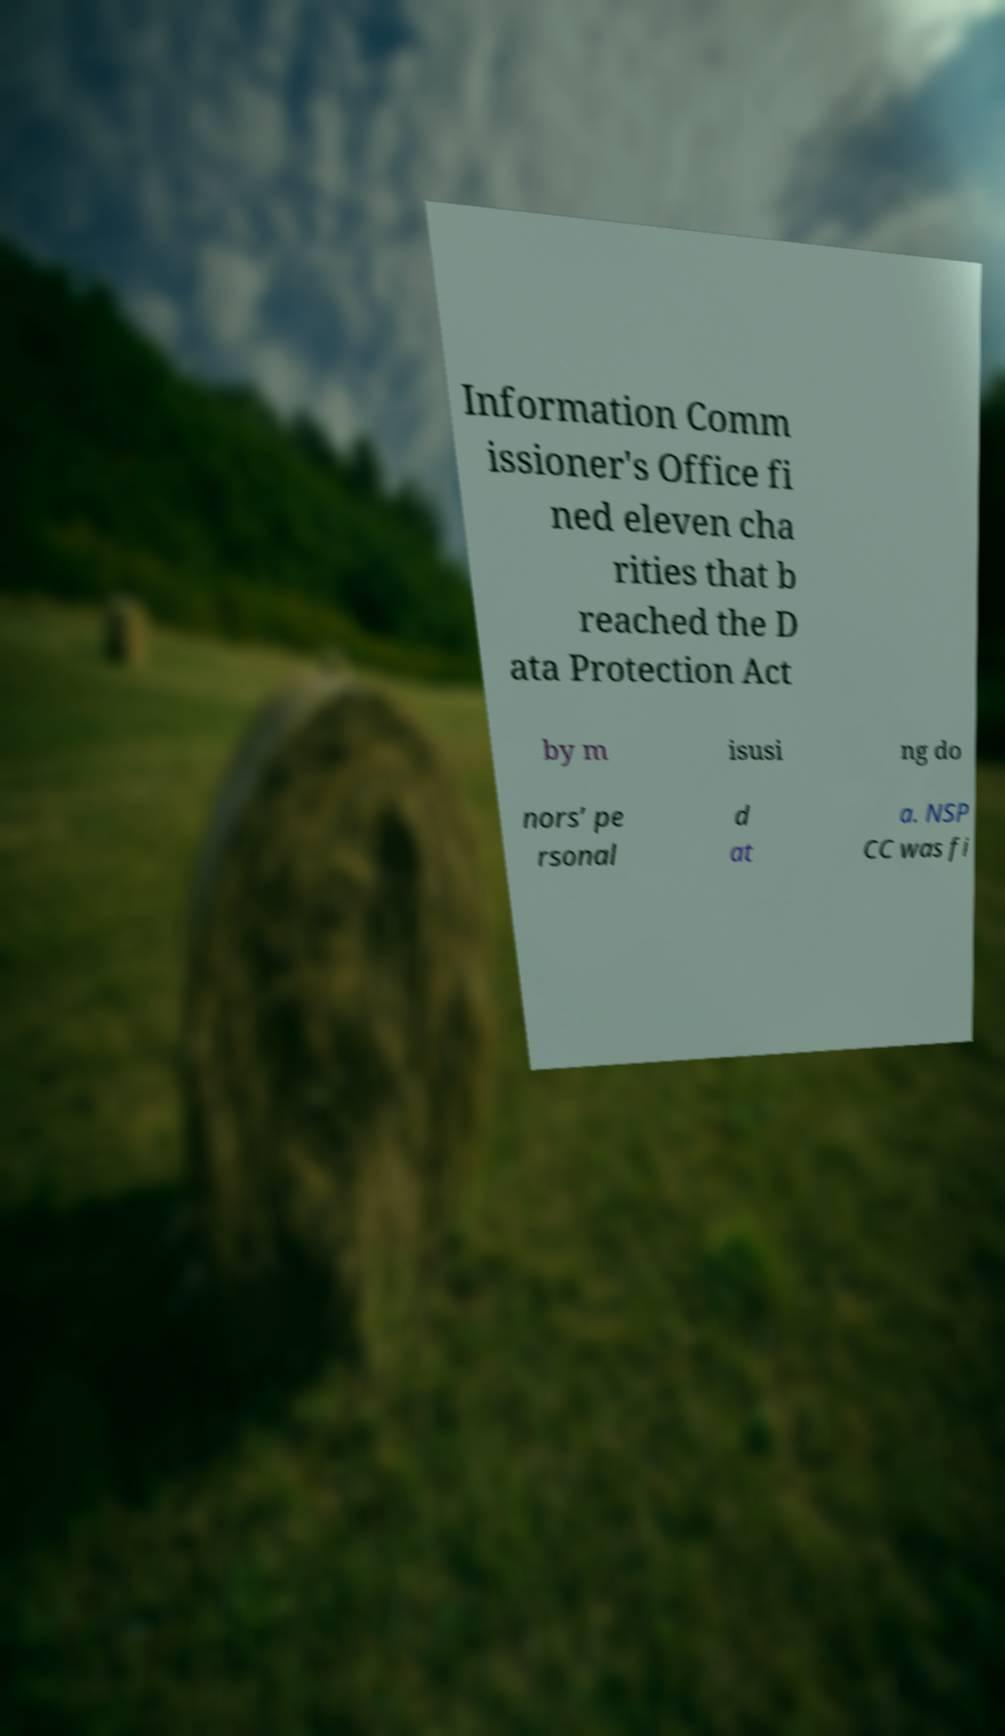There's text embedded in this image that I need extracted. Can you transcribe it verbatim? Information Comm issioner's Office fi ned eleven cha rities that b reached the D ata Protection Act by m isusi ng do nors’ pe rsonal d at a. NSP CC was fi 